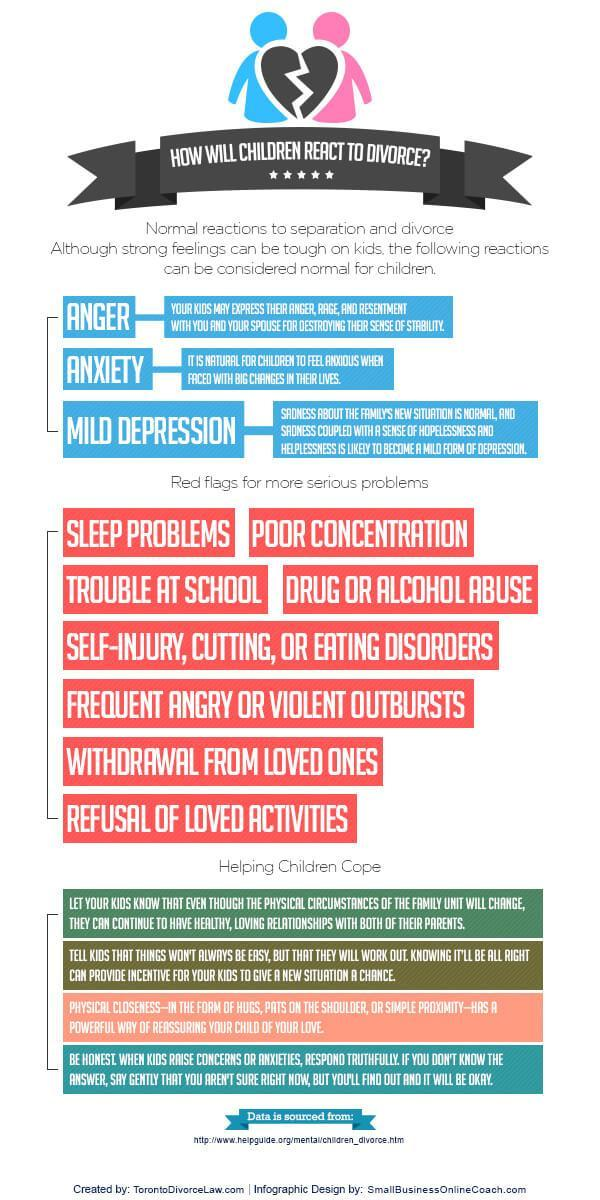How many normal reactions of Children facing Divorce are listed in the infographic?
Answer the question with a short phrase. 3 What are the normal reactions of Children facing Divorce? Anger, Anxiety, Mild Depression Which is the fourth serious problem faced by children when their parents divorce? Drug or Alcohol Abuse Which is the second most serious problem faced by children when their parents divorce? Poor Concentration What is the color of the flag given to Normal reactions of children facing Divorce- green, blue, orange, yellow? blue 